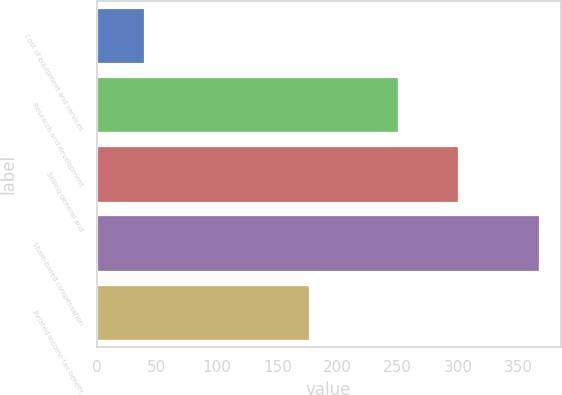<chart> <loc_0><loc_0><loc_500><loc_500><bar_chart><fcel>Cost of equipment and services<fcel>Research and development<fcel>Selling general and<fcel>Share-based compensation<fcel>Related income tax benefit<nl><fcel>39<fcel>250<fcel>300.4<fcel>367<fcel>176<nl></chart> 